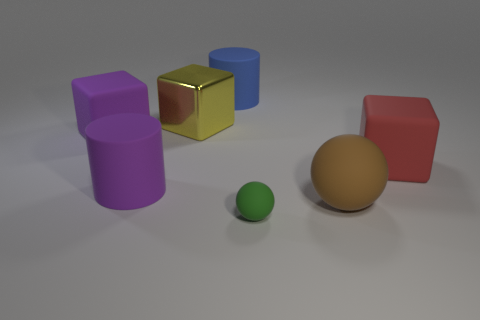Are there an equal number of small green matte balls behind the big blue matte thing and big rubber objects that are in front of the green object?
Your response must be concise. Yes. Is there a tiny thing made of the same material as the large purple block?
Offer a terse response. Yes. Does the big purple object left of the purple matte cylinder have the same material as the big blue thing?
Your answer should be compact. Yes. There is a rubber object that is left of the brown thing and in front of the big purple rubber cylinder; what is its size?
Give a very brief answer. Small. What color is the tiny thing?
Keep it short and to the point. Green. How many large yellow shiny things are there?
Make the answer very short. 1. Is the shape of the big matte object that is in front of the large purple matte cylinder the same as the object that is in front of the brown matte thing?
Your answer should be compact. Yes. What color is the rubber cube behind the block that is to the right of the big matte cylinder that is behind the red block?
Provide a succinct answer. Purple. What color is the object that is in front of the large sphere?
Your answer should be compact. Green. The shiny cube that is the same size as the brown object is what color?
Provide a succinct answer. Yellow. 